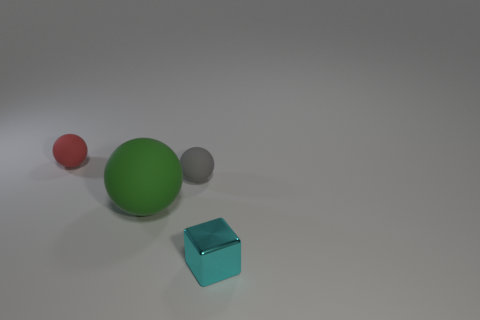Are there more small cyan things behind the block than cyan rubber cylinders?
Keep it short and to the point. No. Are there an equal number of red rubber things that are in front of the cyan object and cyan metallic things that are behind the green matte sphere?
Your answer should be compact. Yes. What color is the thing that is to the left of the small gray thing and in front of the tiny gray object?
Offer a terse response. Green. Is there anything else that has the same size as the gray matte thing?
Your answer should be very brief. Yes. Is the number of cubes that are on the left side of the cyan shiny cube greater than the number of red spheres behind the tiny red rubber ball?
Offer a very short reply. No. There is a sphere that is to the left of the green object; is it the same size as the tiny cube?
Provide a short and direct response. Yes. How many large matte spheres are in front of the rubber object that is behind the tiny rubber thing that is to the right of the tiny red thing?
Make the answer very short. 1. How big is the thing that is both in front of the gray rubber sphere and on the left side of the small metal thing?
Keep it short and to the point. Large. How many other objects are there of the same shape as the cyan metallic thing?
Your response must be concise. 0. There is a tiny cyan metallic block; what number of green spheres are left of it?
Offer a terse response. 1. 